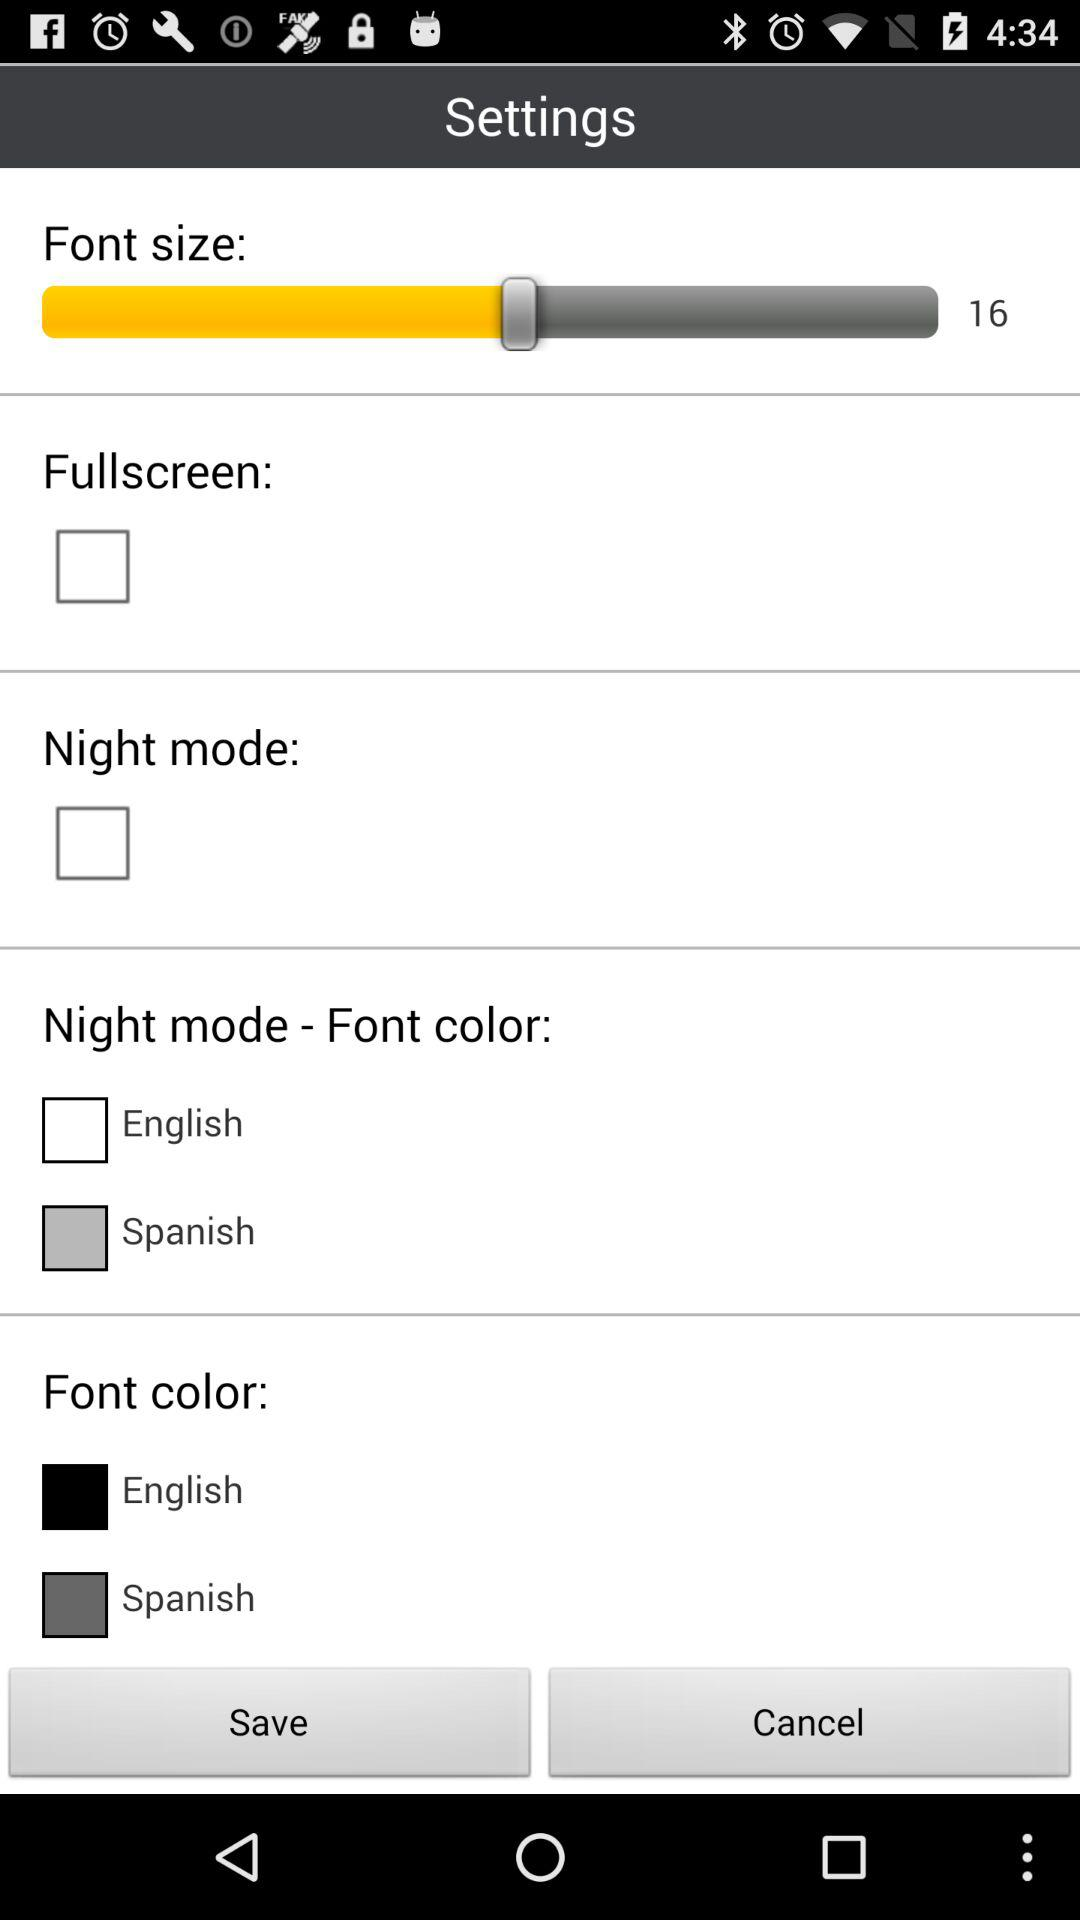What is the selected font size? The selected font size is 16. 